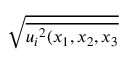Convert formula to latex. <formula><loc_0><loc_0><loc_500><loc_500>\sqrt { \overline { { { u _ { i } } ^ { 2 } ( x _ { 1 } , x _ { 2 } , x _ { 3 } } } }</formula> 